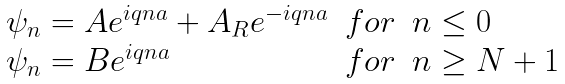<formula> <loc_0><loc_0><loc_500><loc_500>\begin{array} { l l l } \psi _ { n } = A e ^ { i q n a } + A _ { R } e ^ { - i q n a } & f o r & n \leq 0 \\ \psi _ { n } = B e ^ { i q n a } & f o r & n \geq N + 1 \\ \end{array}</formula> 